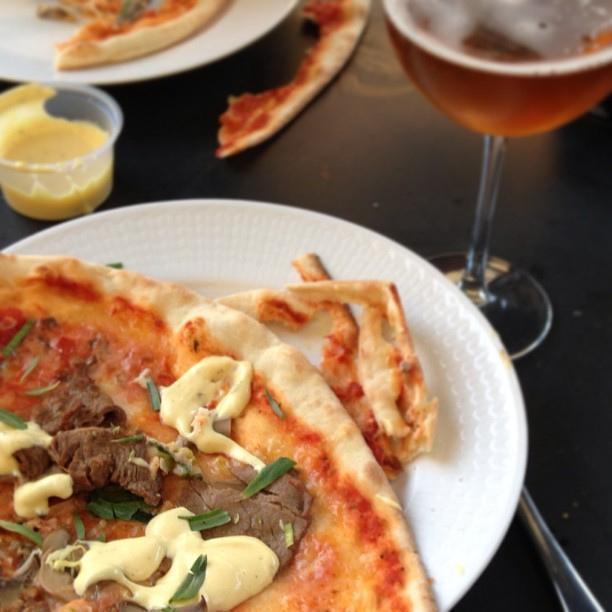How many pizzas are there?
Give a very brief answer. 4. How many people are in the carrier?
Give a very brief answer. 0. 